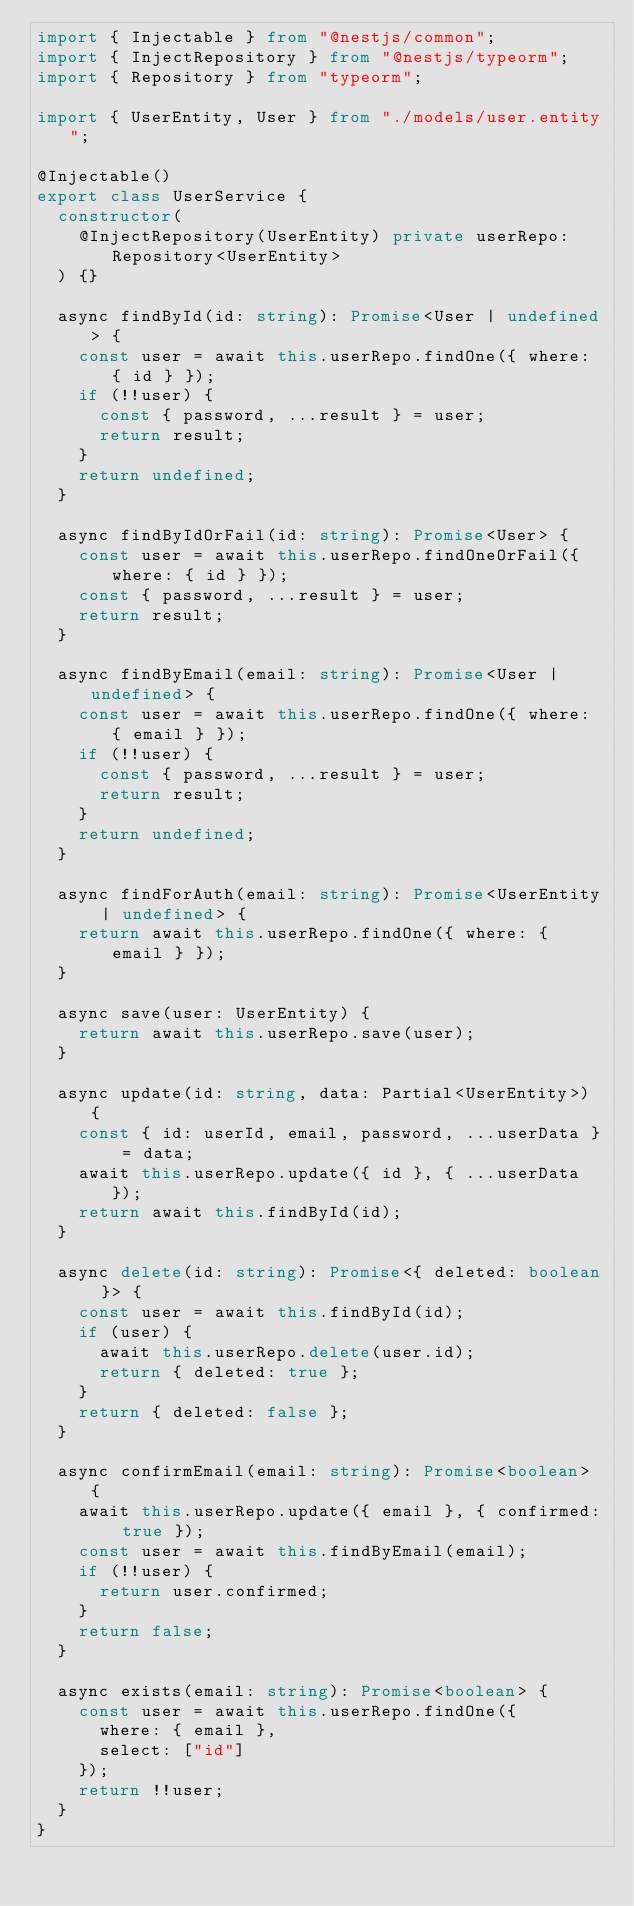Convert code to text. <code><loc_0><loc_0><loc_500><loc_500><_TypeScript_>import { Injectable } from "@nestjs/common";
import { InjectRepository } from "@nestjs/typeorm";
import { Repository } from "typeorm";

import { UserEntity, User } from "./models/user.entity";

@Injectable()
export class UserService {
  constructor(
    @InjectRepository(UserEntity) private userRepo: Repository<UserEntity>
  ) {}

  async findById(id: string): Promise<User | undefined> {
    const user = await this.userRepo.findOne({ where: { id } });
    if (!!user) {
      const { password, ...result } = user;
      return result;
    }
    return undefined;
  }

  async findByIdOrFail(id: string): Promise<User> {
    const user = await this.userRepo.findOneOrFail({ where: { id } });
    const { password, ...result } = user;
    return result;
  }

  async findByEmail(email: string): Promise<User | undefined> {
    const user = await this.userRepo.findOne({ where: { email } });
    if (!!user) {
      const { password, ...result } = user;
      return result;
    }
    return undefined;
  }

  async findForAuth(email: string): Promise<UserEntity | undefined> {
    return await this.userRepo.findOne({ where: { email } });
  }

  async save(user: UserEntity) {
    return await this.userRepo.save(user);
  }

  async update(id: string, data: Partial<UserEntity>) {
    const { id: userId, email, password, ...userData } = data;
    await this.userRepo.update({ id }, { ...userData });
    return await this.findById(id);
  }

  async delete(id: string): Promise<{ deleted: boolean }> {
    const user = await this.findById(id);
    if (user) {
      await this.userRepo.delete(user.id);
      return { deleted: true };
    }
    return { deleted: false };
  }

  async confirmEmail(email: string): Promise<boolean> {
    await this.userRepo.update({ email }, { confirmed: true });
    const user = await this.findByEmail(email);
    if (!!user) {
      return user.confirmed;
    }
    return false;
  }

  async exists(email: string): Promise<boolean> {
    const user = await this.userRepo.findOne({
      where: { email },
      select: ["id"]
    });
    return !!user;
  }
}
</code> 